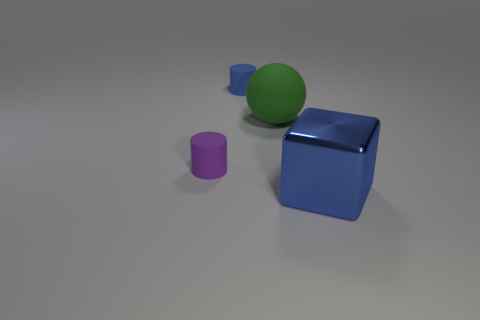Add 1 large green rubber objects. How many objects exist? 5 Subtract all spheres. How many objects are left? 3 Add 1 small cyan shiny things. How many small cyan shiny things exist? 1 Subtract 0 green cylinders. How many objects are left? 4 Subtract all tiny purple cylinders. Subtract all green balls. How many objects are left? 2 Add 2 purple matte cylinders. How many purple matte cylinders are left? 3 